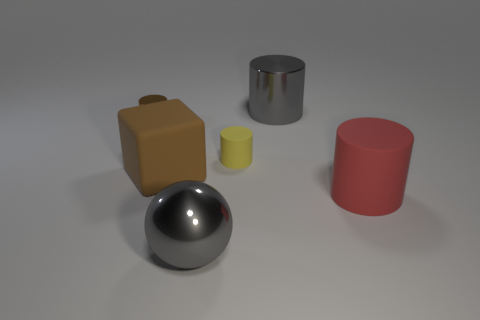Add 1 red cylinders. How many objects exist? 7 Subtract 1 cylinders. How many cylinders are left? 3 Subtract all blue cylinders. Subtract all red balls. How many cylinders are left? 4 Subtract all cylinders. How many objects are left? 2 Subtract 0 brown balls. How many objects are left? 6 Subtract all yellow matte things. Subtract all gray metallic spheres. How many objects are left? 4 Add 2 big gray metal objects. How many big gray metal objects are left? 4 Add 4 yellow cylinders. How many yellow cylinders exist? 5 